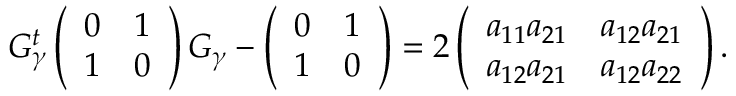Convert formula to latex. <formula><loc_0><loc_0><loc_500><loc_500>G _ { \gamma } ^ { t } \left ( \begin{array} { c } { 0 } \\ { 1 } \end{array} \begin{array} { c c } { 1 } \\ { 0 } \end{array} \right ) G _ { \gamma } - \left ( \begin{array} { c } { 0 } \\ { 1 } \end{array} \begin{array} { c c } { 1 } \\ { 0 } \end{array} \right ) = 2 \left ( \begin{array} { c } { { a _ { 1 1 } a _ { 2 1 } } } \\ { { a _ { 1 2 } a _ { 2 1 } } } \end{array} \begin{array} { c c } { { a _ { 1 2 } a _ { 2 1 } } } \\ { { a _ { 1 2 } a _ { 2 2 } } } \end{array} \right ) .</formula> 